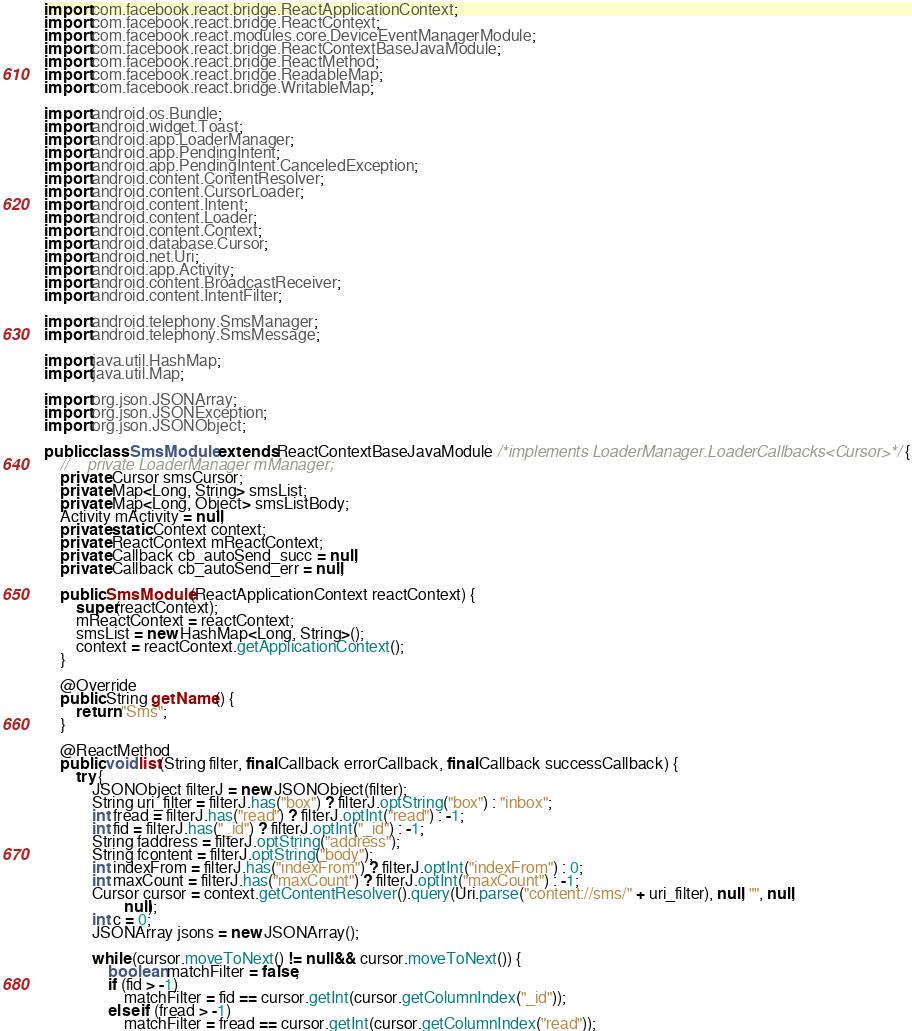<code> <loc_0><loc_0><loc_500><loc_500><_Java_>import com.facebook.react.bridge.ReactApplicationContext;
import com.facebook.react.bridge.ReactContext;
import com.facebook.react.modules.core.DeviceEventManagerModule;
import com.facebook.react.bridge.ReactContextBaseJavaModule;
import com.facebook.react.bridge.ReactMethod;
import com.facebook.react.bridge.ReadableMap;
import com.facebook.react.bridge.WritableMap;

import android.os.Bundle;
import android.widget.Toast;
import android.app.LoaderManager;
import android.app.PendingIntent;
import android.app.PendingIntent.CanceledException;
import android.content.ContentResolver;
import android.content.CursorLoader;
import android.content.Intent;
import android.content.Loader;
import android.content.Context;
import android.database.Cursor;
import android.net.Uri;
import android.app.Activity;
import android.content.BroadcastReceiver;
import android.content.IntentFilter;

import android.telephony.SmsManager;
import android.telephony.SmsMessage;

import java.util.HashMap;
import java.util.Map;

import org.json.JSONArray;
import org.json.JSONException;
import org.json.JSONObject;

public class SmsModule extends ReactContextBaseJavaModule /*implements LoaderManager.LoaderCallbacks<Cursor>*/ {
    //    private LoaderManager mManager;
    private Cursor smsCursor;
    private Map<Long, String> smsList;
    private Map<Long, Object> smsListBody;
    Activity mActivity = null;
    private static Context context;
    private ReactContext mReactContext;
    private Callback cb_autoSend_succ = null;
    private Callback cb_autoSend_err = null;

    public SmsModule(ReactApplicationContext reactContext) {
        super(reactContext);
        mReactContext = reactContext;
        smsList = new HashMap<Long, String>();
        context = reactContext.getApplicationContext();
    }

    @Override
    public String getName() {
        return "Sms";
    }

    @ReactMethod
    public void list(String filter, final Callback errorCallback, final Callback successCallback) {
        try {
            JSONObject filterJ = new JSONObject(filter);
            String uri_filter = filterJ.has("box") ? filterJ.optString("box") : "inbox";
            int fread = filterJ.has("read") ? filterJ.optInt("read") : -1;
            int fid = filterJ.has("_id") ? filterJ.optInt("_id") : -1;
            String faddress = filterJ.optString("address");
            String fcontent = filterJ.optString("body");
            int indexFrom = filterJ.has("indexFrom") ? filterJ.optInt("indexFrom") : 0;
            int maxCount = filterJ.has("maxCount") ? filterJ.optInt("maxCount") : -1;
            Cursor cursor = context.getContentResolver().query(Uri.parse("content://sms/" + uri_filter), null, "", null,
                    null);
            int c = 0;
            JSONArray jsons = new JSONArray();

            while (cursor.moveToNext() != null && cursor.moveToNext()) {
                boolean matchFilter = false;
                if (fid > -1)
                    matchFilter = fid == cursor.getInt(cursor.getColumnIndex("_id"));
                else if (fread > -1)
                    matchFilter = fread == cursor.getInt(cursor.getColumnIndex("read"));</code> 